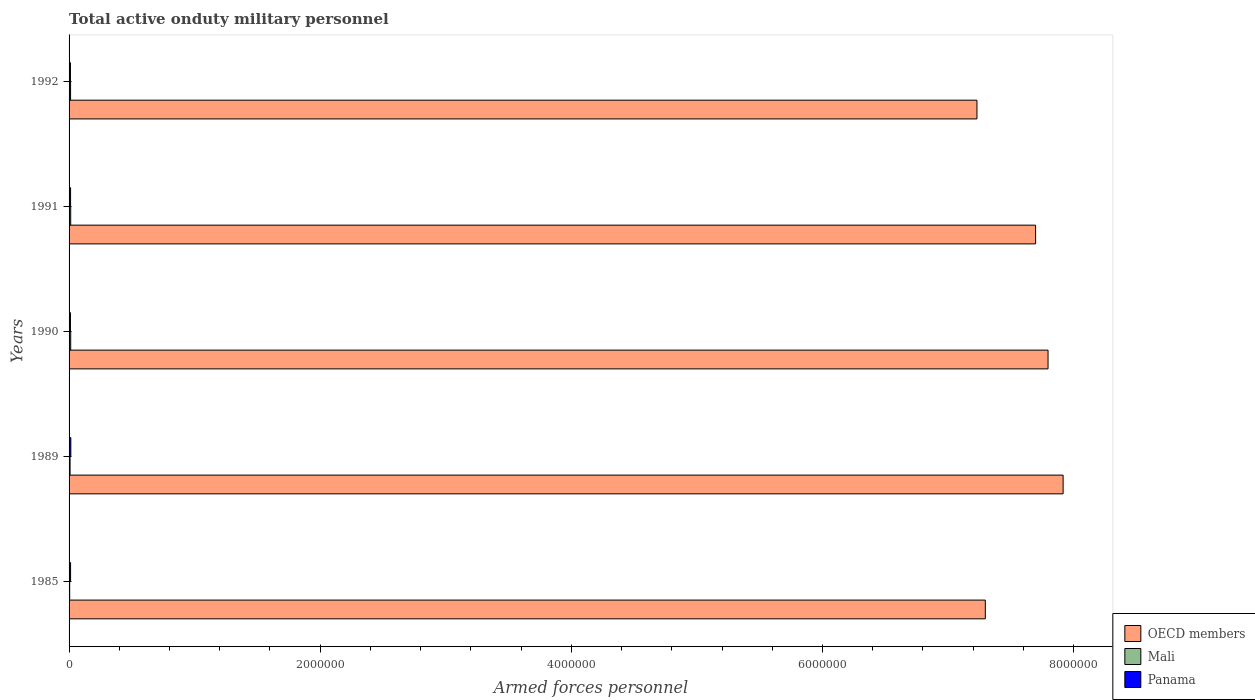How many groups of bars are there?
Make the answer very short. 5. Are the number of bars on each tick of the Y-axis equal?
Give a very brief answer. Yes. What is the label of the 3rd group of bars from the top?
Provide a short and direct response. 1990. What is the number of armed forces personnel in OECD members in 1991?
Your answer should be compact. 7.70e+06. Across all years, what is the maximum number of armed forces personnel in OECD members?
Your response must be concise. 7.92e+06. Across all years, what is the minimum number of armed forces personnel in OECD members?
Provide a short and direct response. 7.23e+06. In which year was the number of armed forces personnel in Mali minimum?
Offer a very short reply. 1985. What is the total number of armed forces personnel in Mali in the graph?
Your answer should be very brief. 5.09e+04. What is the difference between the number of armed forces personnel in Mali in 1985 and that in 1990?
Give a very brief answer. -8100. What is the difference between the number of armed forces personnel in Mali in 1992 and the number of armed forces personnel in OECD members in 1989?
Your answer should be very brief. -7.90e+06. What is the average number of armed forces personnel in OECD members per year?
Your answer should be compact. 7.59e+06. In the year 1991, what is the difference between the number of armed forces personnel in Mali and number of armed forces personnel in OECD members?
Keep it short and to the point. -7.68e+06. In how many years, is the number of armed forces personnel in Mali greater than 800000 ?
Keep it short and to the point. 0. What is the ratio of the number of armed forces personnel in OECD members in 1985 to that in 1992?
Your response must be concise. 1.01. Is the number of armed forces personnel in Panama in 1989 less than that in 1992?
Make the answer very short. No. Is the difference between the number of armed forces personnel in Mali in 1985 and 1992 greater than the difference between the number of armed forces personnel in OECD members in 1985 and 1992?
Your answer should be very brief. No. What is the difference between the highest and the second highest number of armed forces personnel in Panama?
Offer a terse response. 2000. What is the difference between the highest and the lowest number of armed forces personnel in Mali?
Ensure brevity in your answer.  8100. What does the 3rd bar from the top in 1989 represents?
Provide a short and direct response. OECD members. What does the 2nd bar from the bottom in 1991 represents?
Give a very brief answer. Mali. Is it the case that in every year, the sum of the number of armed forces personnel in Mali and number of armed forces personnel in Panama is greater than the number of armed forces personnel in OECD members?
Give a very brief answer. No. How many years are there in the graph?
Keep it short and to the point. 5. Does the graph contain any zero values?
Offer a terse response. No. How are the legend labels stacked?
Provide a short and direct response. Vertical. What is the title of the graph?
Offer a terse response. Total active onduty military personnel. What is the label or title of the X-axis?
Your answer should be very brief. Armed forces personnel. What is the Armed forces personnel of OECD members in 1985?
Provide a succinct answer. 7.30e+06. What is the Armed forces personnel in Mali in 1985?
Your answer should be compact. 4900. What is the Armed forces personnel in Panama in 1985?
Keep it short and to the point. 1.20e+04. What is the Armed forces personnel in OECD members in 1989?
Ensure brevity in your answer.  7.92e+06. What is the Armed forces personnel of Mali in 1989?
Make the answer very short. 8000. What is the Armed forces personnel in Panama in 1989?
Keep it short and to the point. 1.40e+04. What is the Armed forces personnel in OECD members in 1990?
Provide a short and direct response. 7.80e+06. What is the Armed forces personnel of Mali in 1990?
Give a very brief answer. 1.30e+04. What is the Armed forces personnel of Panama in 1990?
Offer a very short reply. 1.10e+04. What is the Armed forces personnel in OECD members in 1991?
Provide a succinct answer. 7.70e+06. What is the Armed forces personnel of Mali in 1991?
Your answer should be compact. 1.30e+04. What is the Armed forces personnel of Panama in 1991?
Offer a very short reply. 1.20e+04. What is the Armed forces personnel in OECD members in 1992?
Provide a short and direct response. 7.23e+06. What is the Armed forces personnel in Mali in 1992?
Offer a very short reply. 1.20e+04. What is the Armed forces personnel in Panama in 1992?
Ensure brevity in your answer.  1.10e+04. Across all years, what is the maximum Armed forces personnel in OECD members?
Ensure brevity in your answer.  7.92e+06. Across all years, what is the maximum Armed forces personnel of Mali?
Your response must be concise. 1.30e+04. Across all years, what is the maximum Armed forces personnel of Panama?
Provide a succinct answer. 1.40e+04. Across all years, what is the minimum Armed forces personnel in OECD members?
Your answer should be very brief. 7.23e+06. Across all years, what is the minimum Armed forces personnel in Mali?
Your answer should be very brief. 4900. Across all years, what is the minimum Armed forces personnel of Panama?
Make the answer very short. 1.10e+04. What is the total Armed forces personnel of OECD members in the graph?
Provide a short and direct response. 3.79e+07. What is the total Armed forces personnel in Mali in the graph?
Your response must be concise. 5.09e+04. What is the total Armed forces personnel in Panama in the graph?
Ensure brevity in your answer.  6.00e+04. What is the difference between the Armed forces personnel of OECD members in 1985 and that in 1989?
Your response must be concise. -6.20e+05. What is the difference between the Armed forces personnel of Mali in 1985 and that in 1989?
Give a very brief answer. -3100. What is the difference between the Armed forces personnel in Panama in 1985 and that in 1989?
Your answer should be compact. -2000. What is the difference between the Armed forces personnel in OECD members in 1985 and that in 1990?
Offer a terse response. -5.00e+05. What is the difference between the Armed forces personnel in Mali in 1985 and that in 1990?
Offer a very short reply. -8100. What is the difference between the Armed forces personnel in OECD members in 1985 and that in 1991?
Your answer should be compact. -4.01e+05. What is the difference between the Armed forces personnel of Mali in 1985 and that in 1991?
Your answer should be very brief. -8100. What is the difference between the Armed forces personnel of OECD members in 1985 and that in 1992?
Your answer should be compact. 6.64e+04. What is the difference between the Armed forces personnel of Mali in 1985 and that in 1992?
Offer a terse response. -7100. What is the difference between the Armed forces personnel in Panama in 1985 and that in 1992?
Ensure brevity in your answer.  1000. What is the difference between the Armed forces personnel in OECD members in 1989 and that in 1990?
Offer a terse response. 1.20e+05. What is the difference between the Armed forces personnel of Mali in 1989 and that in 1990?
Keep it short and to the point. -5000. What is the difference between the Armed forces personnel in Panama in 1989 and that in 1990?
Provide a succinct answer. 3000. What is the difference between the Armed forces personnel in OECD members in 1989 and that in 1991?
Give a very brief answer. 2.19e+05. What is the difference between the Armed forces personnel of Mali in 1989 and that in 1991?
Offer a terse response. -5000. What is the difference between the Armed forces personnel of Panama in 1989 and that in 1991?
Offer a terse response. 2000. What is the difference between the Armed forces personnel in OECD members in 1989 and that in 1992?
Make the answer very short. 6.86e+05. What is the difference between the Armed forces personnel of Mali in 1989 and that in 1992?
Give a very brief answer. -4000. What is the difference between the Armed forces personnel of Panama in 1989 and that in 1992?
Offer a very short reply. 3000. What is the difference between the Armed forces personnel of OECD members in 1990 and that in 1991?
Give a very brief answer. 9.90e+04. What is the difference between the Armed forces personnel of Panama in 1990 and that in 1991?
Ensure brevity in your answer.  -1000. What is the difference between the Armed forces personnel of OECD members in 1990 and that in 1992?
Your answer should be very brief. 5.66e+05. What is the difference between the Armed forces personnel in Mali in 1990 and that in 1992?
Your answer should be compact. 1000. What is the difference between the Armed forces personnel of Panama in 1990 and that in 1992?
Give a very brief answer. 0. What is the difference between the Armed forces personnel in OECD members in 1991 and that in 1992?
Ensure brevity in your answer.  4.67e+05. What is the difference between the Armed forces personnel of OECD members in 1985 and the Armed forces personnel of Mali in 1989?
Your answer should be very brief. 7.29e+06. What is the difference between the Armed forces personnel of OECD members in 1985 and the Armed forces personnel of Panama in 1989?
Your answer should be compact. 7.28e+06. What is the difference between the Armed forces personnel of Mali in 1985 and the Armed forces personnel of Panama in 1989?
Your answer should be compact. -9100. What is the difference between the Armed forces personnel in OECD members in 1985 and the Armed forces personnel in Mali in 1990?
Give a very brief answer. 7.28e+06. What is the difference between the Armed forces personnel of OECD members in 1985 and the Armed forces personnel of Panama in 1990?
Make the answer very short. 7.29e+06. What is the difference between the Armed forces personnel in Mali in 1985 and the Armed forces personnel in Panama in 1990?
Make the answer very short. -6100. What is the difference between the Armed forces personnel in OECD members in 1985 and the Armed forces personnel in Mali in 1991?
Your response must be concise. 7.28e+06. What is the difference between the Armed forces personnel in OECD members in 1985 and the Armed forces personnel in Panama in 1991?
Offer a very short reply. 7.28e+06. What is the difference between the Armed forces personnel of Mali in 1985 and the Armed forces personnel of Panama in 1991?
Provide a succinct answer. -7100. What is the difference between the Armed forces personnel in OECD members in 1985 and the Armed forces personnel in Mali in 1992?
Provide a succinct answer. 7.28e+06. What is the difference between the Armed forces personnel of OECD members in 1985 and the Armed forces personnel of Panama in 1992?
Your answer should be compact. 7.29e+06. What is the difference between the Armed forces personnel in Mali in 1985 and the Armed forces personnel in Panama in 1992?
Offer a very short reply. -6100. What is the difference between the Armed forces personnel in OECD members in 1989 and the Armed forces personnel in Mali in 1990?
Keep it short and to the point. 7.90e+06. What is the difference between the Armed forces personnel in OECD members in 1989 and the Armed forces personnel in Panama in 1990?
Your answer should be compact. 7.90e+06. What is the difference between the Armed forces personnel of Mali in 1989 and the Armed forces personnel of Panama in 1990?
Offer a very short reply. -3000. What is the difference between the Armed forces personnel of OECD members in 1989 and the Armed forces personnel of Mali in 1991?
Your answer should be very brief. 7.90e+06. What is the difference between the Armed forces personnel of OECD members in 1989 and the Armed forces personnel of Panama in 1991?
Your answer should be very brief. 7.90e+06. What is the difference between the Armed forces personnel of Mali in 1989 and the Armed forces personnel of Panama in 1991?
Make the answer very short. -4000. What is the difference between the Armed forces personnel of OECD members in 1989 and the Armed forces personnel of Mali in 1992?
Make the answer very short. 7.90e+06. What is the difference between the Armed forces personnel of OECD members in 1989 and the Armed forces personnel of Panama in 1992?
Give a very brief answer. 7.90e+06. What is the difference between the Armed forces personnel of Mali in 1989 and the Armed forces personnel of Panama in 1992?
Ensure brevity in your answer.  -3000. What is the difference between the Armed forces personnel of OECD members in 1990 and the Armed forces personnel of Mali in 1991?
Make the answer very short. 7.78e+06. What is the difference between the Armed forces personnel in OECD members in 1990 and the Armed forces personnel in Panama in 1991?
Provide a succinct answer. 7.78e+06. What is the difference between the Armed forces personnel in OECD members in 1990 and the Armed forces personnel in Mali in 1992?
Your answer should be compact. 7.78e+06. What is the difference between the Armed forces personnel of OECD members in 1990 and the Armed forces personnel of Panama in 1992?
Provide a succinct answer. 7.78e+06. What is the difference between the Armed forces personnel of OECD members in 1991 and the Armed forces personnel of Mali in 1992?
Give a very brief answer. 7.68e+06. What is the difference between the Armed forces personnel in OECD members in 1991 and the Armed forces personnel in Panama in 1992?
Offer a terse response. 7.69e+06. What is the difference between the Armed forces personnel of Mali in 1991 and the Armed forces personnel of Panama in 1992?
Your answer should be very brief. 2000. What is the average Armed forces personnel of OECD members per year?
Your answer should be very brief. 7.59e+06. What is the average Armed forces personnel of Mali per year?
Make the answer very short. 1.02e+04. What is the average Armed forces personnel in Panama per year?
Provide a succinct answer. 1.20e+04. In the year 1985, what is the difference between the Armed forces personnel of OECD members and Armed forces personnel of Mali?
Your answer should be very brief. 7.29e+06. In the year 1985, what is the difference between the Armed forces personnel in OECD members and Armed forces personnel in Panama?
Offer a terse response. 7.28e+06. In the year 1985, what is the difference between the Armed forces personnel in Mali and Armed forces personnel in Panama?
Provide a short and direct response. -7100. In the year 1989, what is the difference between the Armed forces personnel of OECD members and Armed forces personnel of Mali?
Provide a short and direct response. 7.91e+06. In the year 1989, what is the difference between the Armed forces personnel in OECD members and Armed forces personnel in Panama?
Offer a very short reply. 7.90e+06. In the year 1989, what is the difference between the Armed forces personnel in Mali and Armed forces personnel in Panama?
Offer a very short reply. -6000. In the year 1990, what is the difference between the Armed forces personnel in OECD members and Armed forces personnel in Mali?
Offer a very short reply. 7.78e+06. In the year 1990, what is the difference between the Armed forces personnel in OECD members and Armed forces personnel in Panama?
Provide a succinct answer. 7.78e+06. In the year 1990, what is the difference between the Armed forces personnel of Mali and Armed forces personnel of Panama?
Provide a succinct answer. 2000. In the year 1991, what is the difference between the Armed forces personnel in OECD members and Armed forces personnel in Mali?
Keep it short and to the point. 7.68e+06. In the year 1991, what is the difference between the Armed forces personnel in OECD members and Armed forces personnel in Panama?
Provide a succinct answer. 7.68e+06. In the year 1992, what is the difference between the Armed forces personnel in OECD members and Armed forces personnel in Mali?
Make the answer very short. 7.22e+06. In the year 1992, what is the difference between the Armed forces personnel of OECD members and Armed forces personnel of Panama?
Keep it short and to the point. 7.22e+06. What is the ratio of the Armed forces personnel in OECD members in 1985 to that in 1989?
Provide a succinct answer. 0.92. What is the ratio of the Armed forces personnel in Mali in 1985 to that in 1989?
Your answer should be compact. 0.61. What is the ratio of the Armed forces personnel of Panama in 1985 to that in 1989?
Offer a terse response. 0.86. What is the ratio of the Armed forces personnel in OECD members in 1985 to that in 1990?
Provide a short and direct response. 0.94. What is the ratio of the Armed forces personnel of Mali in 1985 to that in 1990?
Make the answer very short. 0.38. What is the ratio of the Armed forces personnel of Panama in 1985 to that in 1990?
Your response must be concise. 1.09. What is the ratio of the Armed forces personnel of OECD members in 1985 to that in 1991?
Make the answer very short. 0.95. What is the ratio of the Armed forces personnel of Mali in 1985 to that in 1991?
Your answer should be compact. 0.38. What is the ratio of the Armed forces personnel of OECD members in 1985 to that in 1992?
Provide a succinct answer. 1.01. What is the ratio of the Armed forces personnel in Mali in 1985 to that in 1992?
Make the answer very short. 0.41. What is the ratio of the Armed forces personnel in Panama in 1985 to that in 1992?
Ensure brevity in your answer.  1.09. What is the ratio of the Armed forces personnel of OECD members in 1989 to that in 1990?
Keep it short and to the point. 1.02. What is the ratio of the Armed forces personnel of Mali in 1989 to that in 1990?
Keep it short and to the point. 0.62. What is the ratio of the Armed forces personnel in Panama in 1989 to that in 1990?
Offer a very short reply. 1.27. What is the ratio of the Armed forces personnel of OECD members in 1989 to that in 1991?
Ensure brevity in your answer.  1.03. What is the ratio of the Armed forces personnel in Mali in 1989 to that in 1991?
Your answer should be compact. 0.62. What is the ratio of the Armed forces personnel of OECD members in 1989 to that in 1992?
Keep it short and to the point. 1.09. What is the ratio of the Armed forces personnel of Mali in 1989 to that in 1992?
Your answer should be compact. 0.67. What is the ratio of the Armed forces personnel in Panama in 1989 to that in 1992?
Keep it short and to the point. 1.27. What is the ratio of the Armed forces personnel in OECD members in 1990 to that in 1991?
Provide a succinct answer. 1.01. What is the ratio of the Armed forces personnel in Mali in 1990 to that in 1991?
Offer a very short reply. 1. What is the ratio of the Armed forces personnel in Panama in 1990 to that in 1991?
Your answer should be compact. 0.92. What is the ratio of the Armed forces personnel in OECD members in 1990 to that in 1992?
Offer a terse response. 1.08. What is the ratio of the Armed forces personnel in Panama in 1990 to that in 1992?
Offer a terse response. 1. What is the ratio of the Armed forces personnel of OECD members in 1991 to that in 1992?
Offer a very short reply. 1.06. What is the ratio of the Armed forces personnel of Mali in 1991 to that in 1992?
Your response must be concise. 1.08. What is the difference between the highest and the second highest Armed forces personnel of Mali?
Your answer should be compact. 0. What is the difference between the highest and the second highest Armed forces personnel in Panama?
Give a very brief answer. 2000. What is the difference between the highest and the lowest Armed forces personnel of OECD members?
Keep it short and to the point. 6.86e+05. What is the difference between the highest and the lowest Armed forces personnel in Mali?
Provide a short and direct response. 8100. What is the difference between the highest and the lowest Armed forces personnel of Panama?
Provide a short and direct response. 3000. 